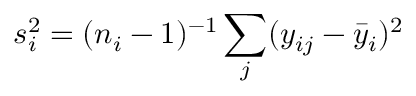<formula> <loc_0><loc_0><loc_500><loc_500>s _ { i } ^ { 2 } = ( n _ { i } - 1 ) ^ { - 1 } \sum _ { j } ( y _ { i j } - { \bar { y } } _ { i } ) ^ { 2 }</formula> 